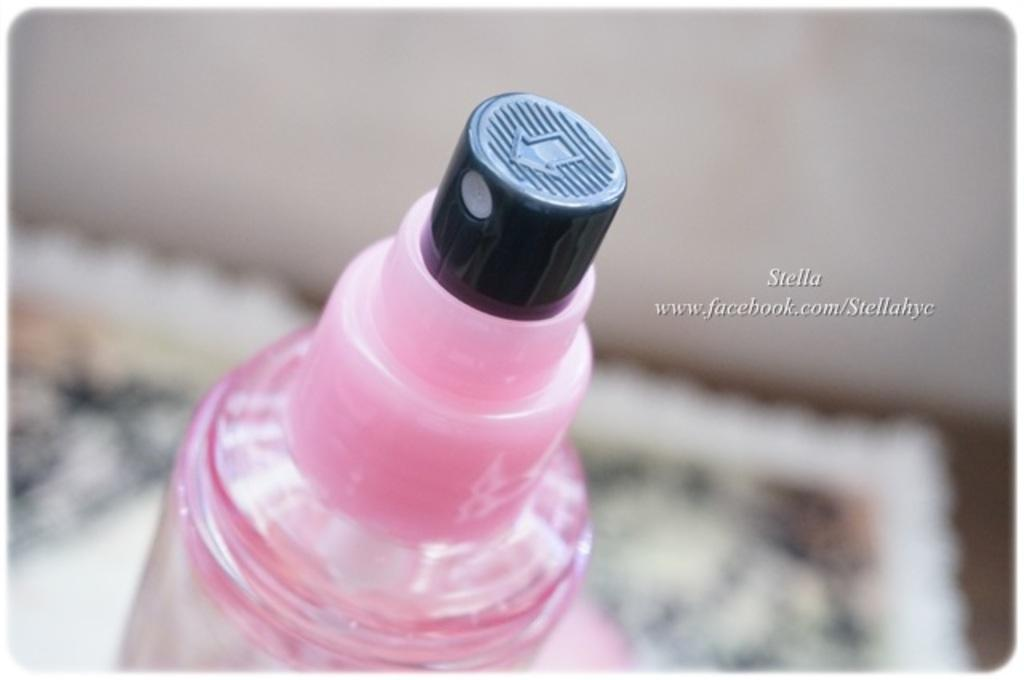What object can be seen in the image? There is a bottle in the image. What type of cub is visible in the image? There is no cub present in the image; only a bottle is visible. What border is depicted in the image? There is no border present in the image; only a bottle is visible. 